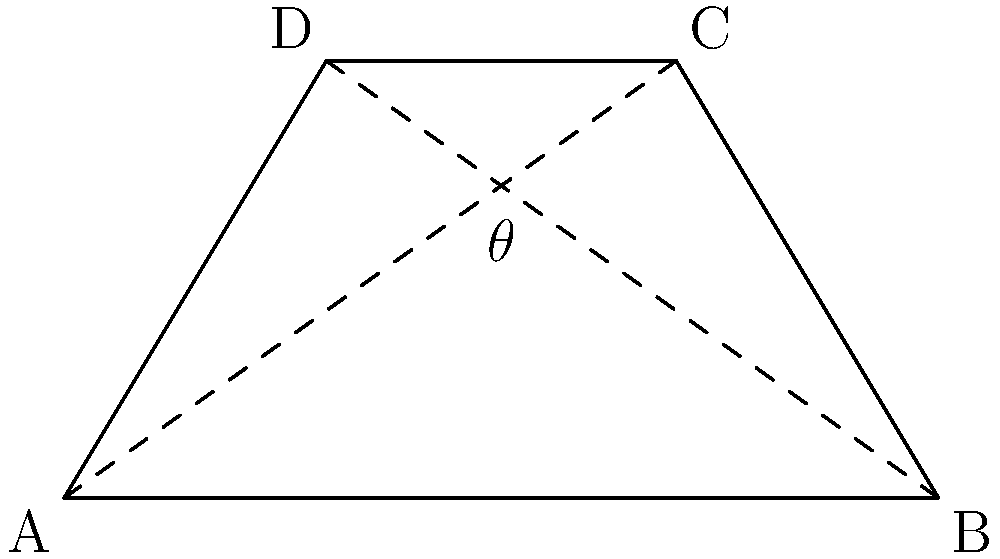During a training session at Huish Park, you're demonstrating a passing drill. Two passes are made simultaneously: one from corner A to C, and another from corner B to D on a rectangular section of the pitch. What is the angle $\theta$ between these two passing lines? Let's approach this step-by-step:

1) The pitch section forms a rectangle, so we know that angles BAD and ABC are both 90°.

2) The passing lines AC and BD are the diagonals of this rectangle. In any rectangle, the diagonals bisect each other at equal angles.

3) This means that the angle between the diagonals ($\theta$) is supplementary to the angle formed by a diagonal and a side of the rectangle. In other words:

   $\theta + \angle BAC = 180°$

4) In a rectangle, the tangent of the angle between a diagonal and the longer side is equal to the ratio of the shorter side to the longer side. If we assume the width of the pitch section is $w$ and the length is $l$, then:

   $\tan(\angle BAC) = \frac{w}{l}$

5) Therefore, $\angle BAC = \arctan(\frac{w}{l})$

6) Now we can find $\theta$:

   $\theta = 180° - 2\arctan(\frac{w}{l})$

7) The exact value would depend on the dimensions of the pitch section. However, on a standard football pitch, the width to length ratio is typically close to 2:3.

8) If we use this ratio:

   $\theta = 180° - 2\arctan(\frac{2}{3}) \approx 73.74°$
Answer: $73.74°$ (assuming a typical 2:3 width-to-length ratio) 